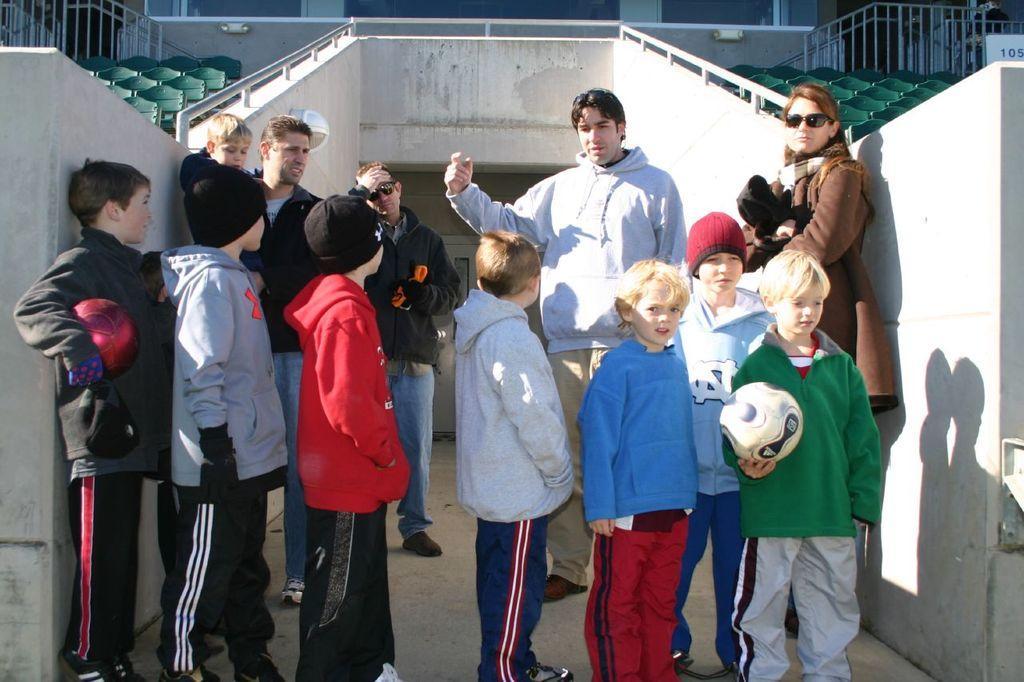Describe this image in one or two sentences. In the picture I can see children's. On the right side of the image I can see one boy is holding the ball. On the left and right side of the image I can see the seats. 